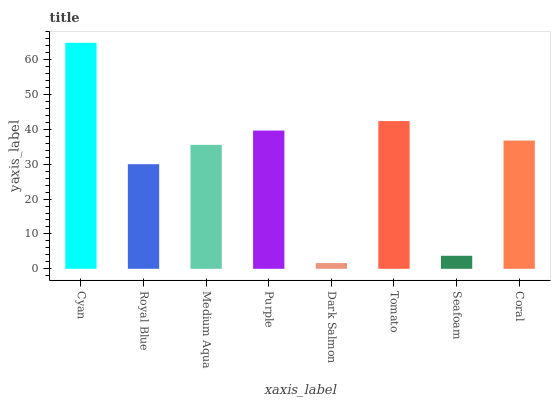Is Dark Salmon the minimum?
Answer yes or no. Yes. Is Cyan the maximum?
Answer yes or no. Yes. Is Royal Blue the minimum?
Answer yes or no. No. Is Royal Blue the maximum?
Answer yes or no. No. Is Cyan greater than Royal Blue?
Answer yes or no. Yes. Is Royal Blue less than Cyan?
Answer yes or no. Yes. Is Royal Blue greater than Cyan?
Answer yes or no. No. Is Cyan less than Royal Blue?
Answer yes or no. No. Is Coral the high median?
Answer yes or no. Yes. Is Medium Aqua the low median?
Answer yes or no. Yes. Is Purple the high median?
Answer yes or no. No. Is Cyan the low median?
Answer yes or no. No. 